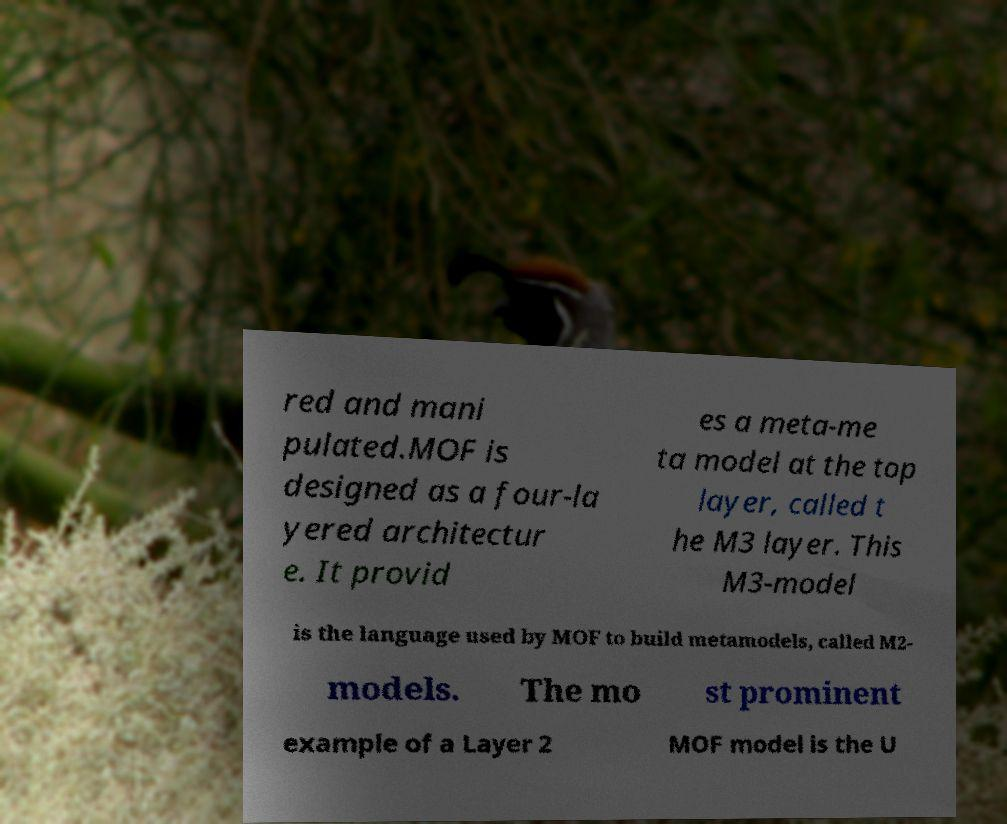For documentation purposes, I need the text within this image transcribed. Could you provide that? red and mani pulated.MOF is designed as a four-la yered architectur e. It provid es a meta-me ta model at the top layer, called t he M3 layer. This M3-model is the language used by MOF to build metamodels, called M2- models. The mo st prominent example of a Layer 2 MOF model is the U 